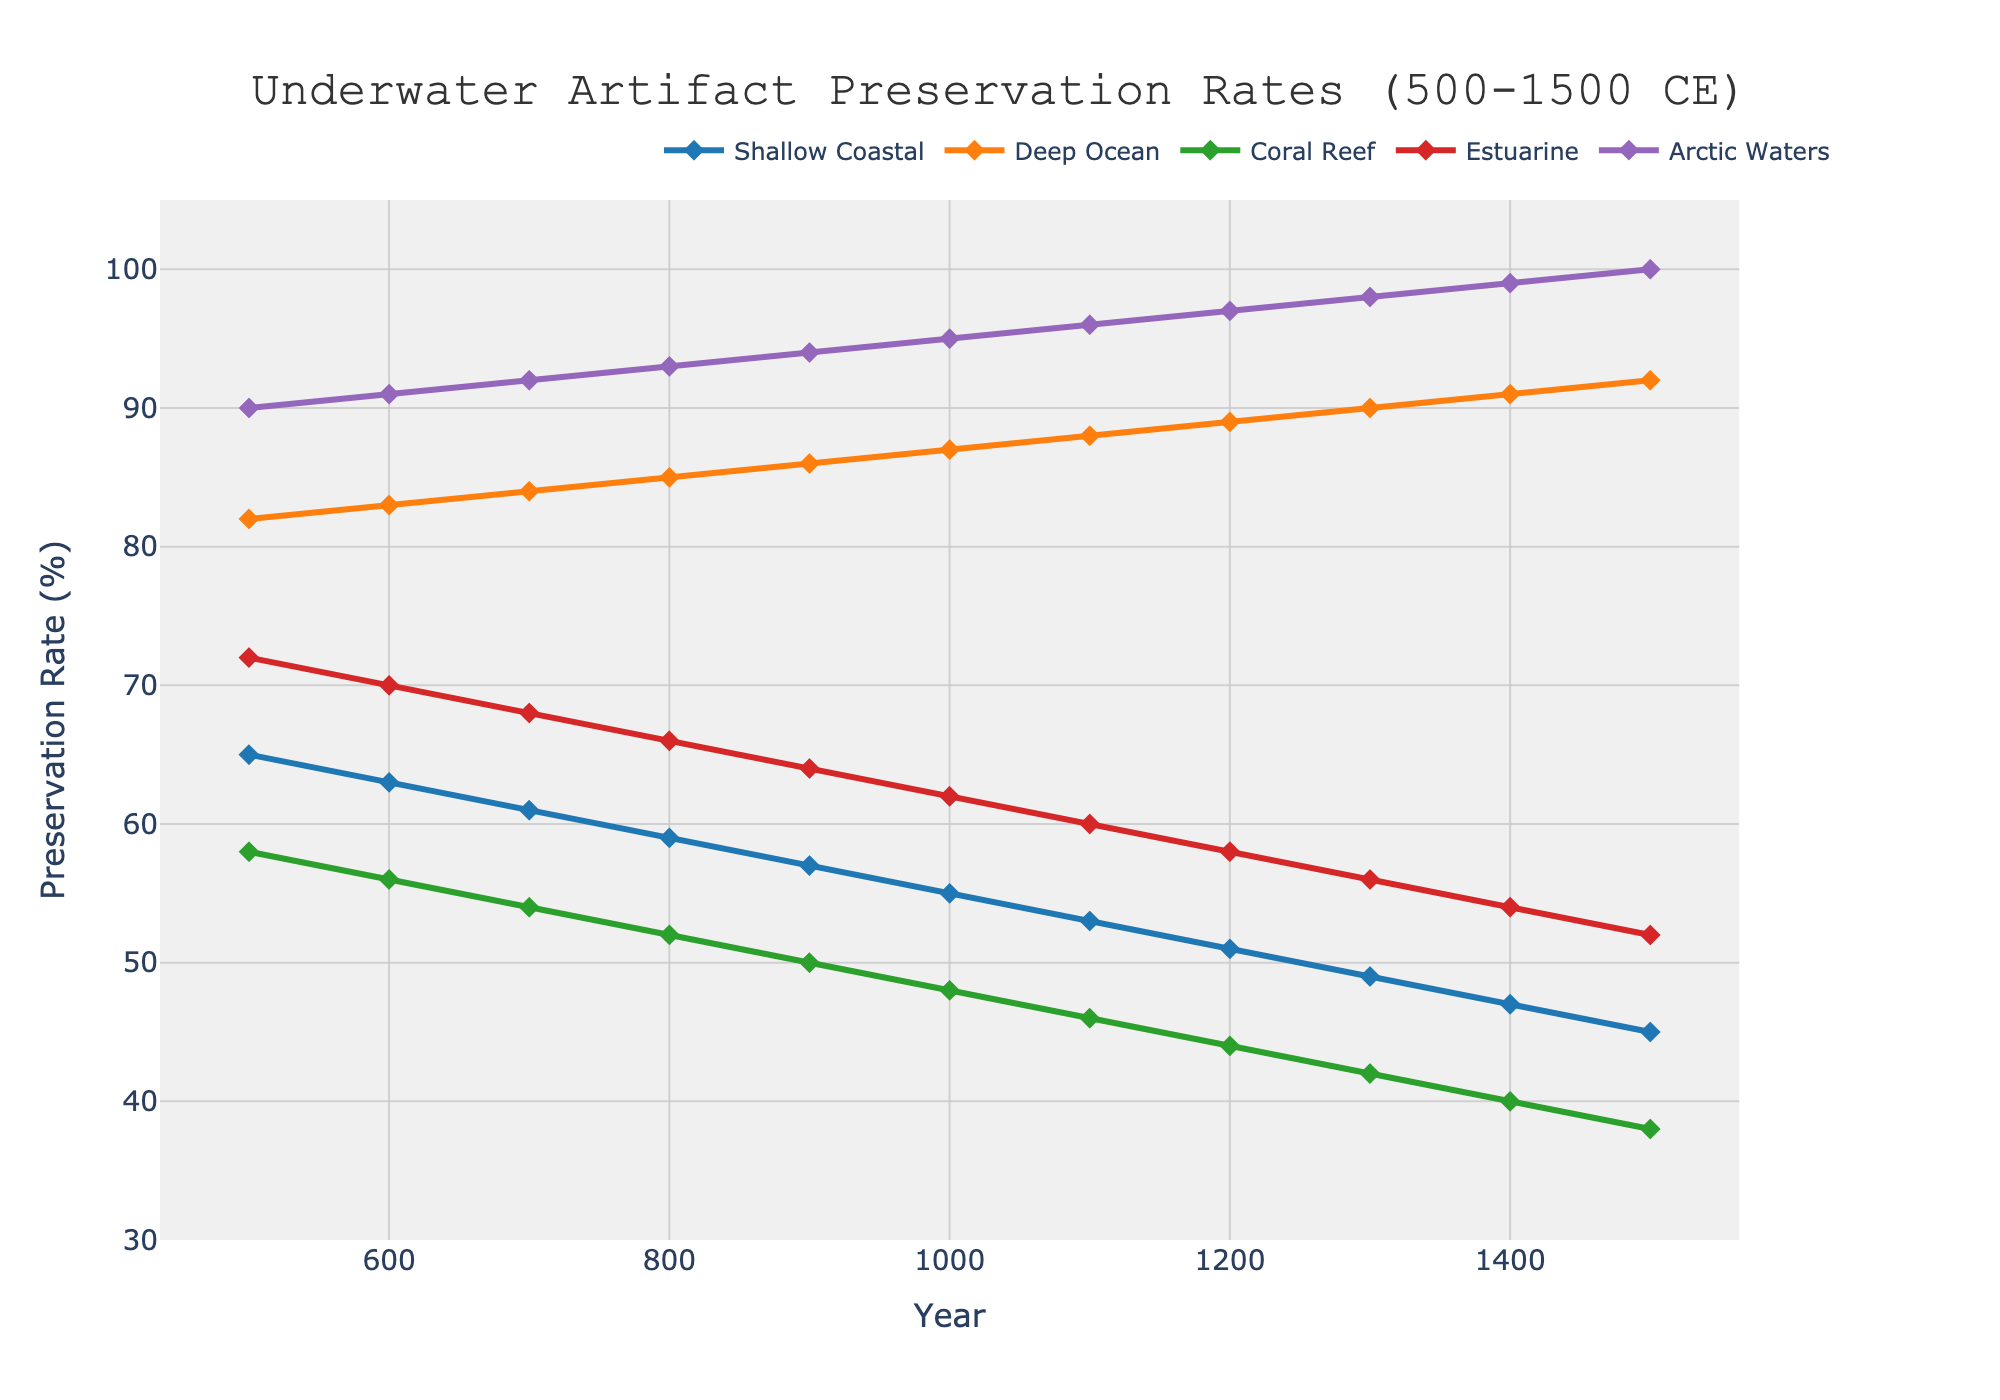What is the overall trend in preservation rates for Shallow Coastal environments from 500 to 1500 CE? The plot shows a continuous decline in the preservation rates for Shallow Coastal environments as you move from left to right on the x-axis (Year 500 to Year 1500). This suggests a decreasing trend.
Answer: Decreasing Which marine environment shows the highest preservation rate in the year 1500? By observing the highest line at the year 1500 on the x-axis, Arctic Waters stand out compared to others with the top-most position.
Answer: Arctic Waters How do preservation rates in Estuarine environments change between 800 CE and 1400 CE? On the plot, find the values for Estuarine environments at 800 CE and 1400 CE. The preservation rate decreases from 66% at 800 CE to 54% at 1400 CE.
Answer: Decrease Compare the preservation rates for Deep Ocean and Coral Reef in the year 1200 CE. Which has a higher value? Look at the y-values for Deep Ocean and Coral Reef at the year 1200 on the x-axis. Deep Ocean has 89%, while Coral Reef has 44%.
Answer: Deep Ocean What is the difference in preservation rates between Shallow Coastal and Arctic Waters in the year 1100 CE? Find the preservation rates at 1100 CE for both Shallow Coastal (53%) and Arctic Waters (96%). The difference is 96% - 53%.
Answer: 43% Calculate the average preservation rate for the Estuarine environment over the entire period (500-1500 CE). Sum the values for Estuarine at all years and divide by the number of years: (72+70+68+66+64+62+60+58+56+54+52)/11. The average is approximately 61.3%.
Answer: 61.3% Which environment shows the least variability in preservation rates over the period? By visually inspecting the plot, the Deep Ocean line appears the most stable and consistent, i.e., with the least fluctuations.
Answer: Deep Ocean In what year do preservation rates for Coral Reef drop below 50%? Observe the Coral Reef line and find the year where it crosses below the 50% mark; it happens between 800 CE and 900 CE.
Answer: 900 CE What is the total decrease in preservation rate for Shallow Coastal environments from 500 CE to 1500 CE? Find the preservation rates for 500 CE (65%) and 1500 CE (45%) for Shallow Coastal. The total decrease is 65% - 45%.
Answer: 20% 